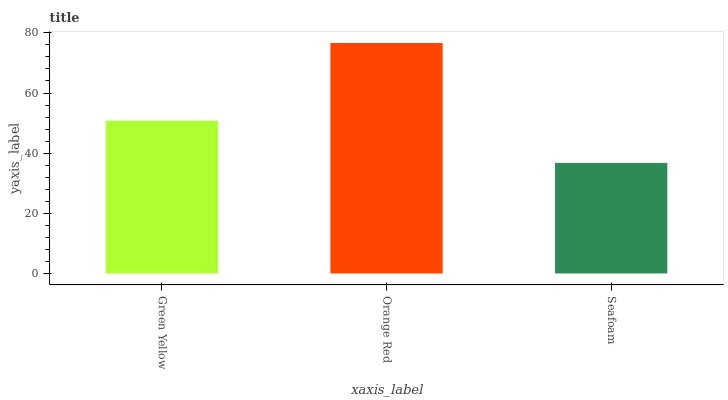Is Seafoam the minimum?
Answer yes or no. Yes. Is Orange Red the maximum?
Answer yes or no. Yes. Is Orange Red the minimum?
Answer yes or no. No. Is Seafoam the maximum?
Answer yes or no. No. Is Orange Red greater than Seafoam?
Answer yes or no. Yes. Is Seafoam less than Orange Red?
Answer yes or no. Yes. Is Seafoam greater than Orange Red?
Answer yes or no. No. Is Orange Red less than Seafoam?
Answer yes or no. No. Is Green Yellow the high median?
Answer yes or no. Yes. Is Green Yellow the low median?
Answer yes or no. Yes. Is Seafoam the high median?
Answer yes or no. No. Is Seafoam the low median?
Answer yes or no. No. 